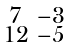<formula> <loc_0><loc_0><loc_500><loc_500>\begin{smallmatrix} 7 & - 3 \\ 1 2 & - 5 \end{smallmatrix}</formula> 